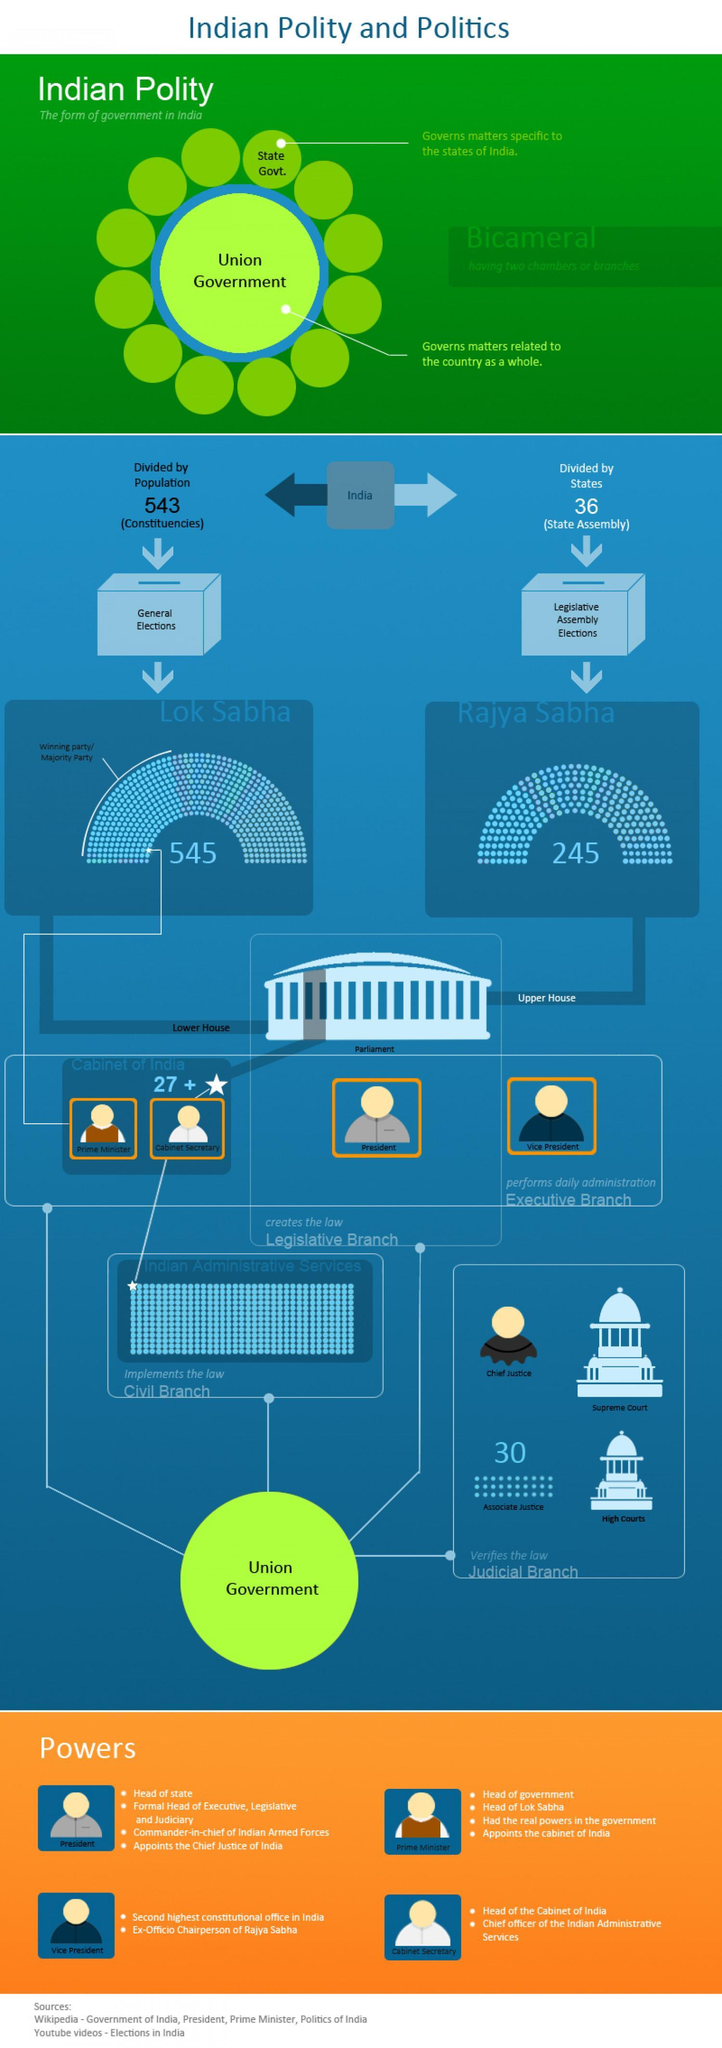How many members are there in Lok Sabha in India?
Answer the question with a short phrase. 545 What is the lower house of India's bicameral Parliament called? Lok Sabha How many members are there in Rajya Sabha in India? 245 How many Parliamentary constituencies are there in India? 543 What election is carried out to elect the Rajya Sabha members? Legislative Assembly Elections What is the upper house of the bicameral Parliament of India? Rajya Sabha Which government governs the matters related to the whole country? Union Government 